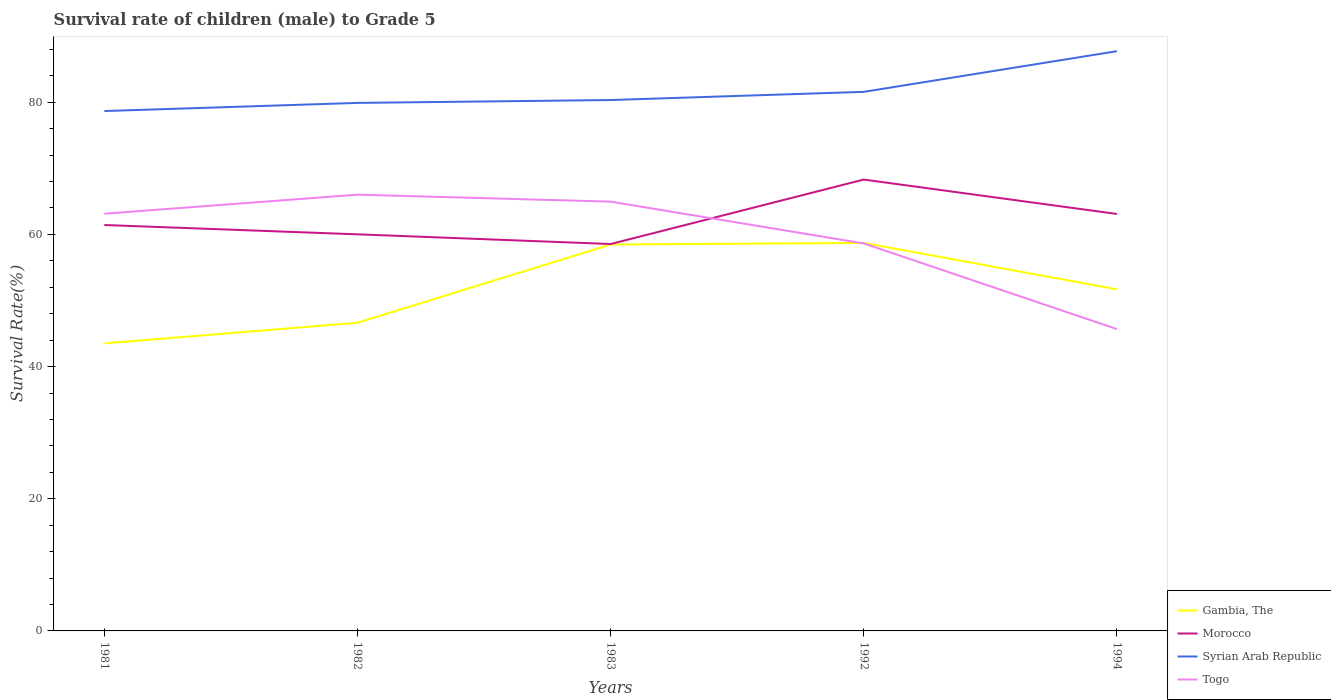Is the number of lines equal to the number of legend labels?
Provide a succinct answer. Yes. Across all years, what is the maximum survival rate of male children to grade 5 in Syrian Arab Republic?
Provide a short and direct response. 78.67. What is the total survival rate of male children to grade 5 in Gambia, The in the graph?
Give a very brief answer. -14.96. What is the difference between the highest and the second highest survival rate of male children to grade 5 in Morocco?
Offer a terse response. 9.75. Is the survival rate of male children to grade 5 in Togo strictly greater than the survival rate of male children to grade 5 in Morocco over the years?
Your response must be concise. No. How many years are there in the graph?
Your answer should be very brief. 5. What is the difference between two consecutive major ticks on the Y-axis?
Your answer should be very brief. 20. Where does the legend appear in the graph?
Give a very brief answer. Bottom right. How many legend labels are there?
Keep it short and to the point. 4. What is the title of the graph?
Make the answer very short. Survival rate of children (male) to Grade 5. Does "Argentina" appear as one of the legend labels in the graph?
Ensure brevity in your answer.  No. What is the label or title of the X-axis?
Provide a succinct answer. Years. What is the label or title of the Y-axis?
Ensure brevity in your answer.  Survival Rate(%). What is the Survival Rate(%) of Gambia, The in 1981?
Your response must be concise. 43.51. What is the Survival Rate(%) of Morocco in 1981?
Make the answer very short. 61.42. What is the Survival Rate(%) in Syrian Arab Republic in 1981?
Your response must be concise. 78.67. What is the Survival Rate(%) of Togo in 1981?
Offer a very short reply. 63.13. What is the Survival Rate(%) in Gambia, The in 1982?
Your answer should be compact. 46.63. What is the Survival Rate(%) in Morocco in 1982?
Your answer should be compact. 60.01. What is the Survival Rate(%) of Syrian Arab Republic in 1982?
Make the answer very short. 79.9. What is the Survival Rate(%) in Togo in 1982?
Offer a very short reply. 66.01. What is the Survival Rate(%) of Gambia, The in 1983?
Give a very brief answer. 58.47. What is the Survival Rate(%) in Morocco in 1983?
Ensure brevity in your answer.  58.55. What is the Survival Rate(%) in Syrian Arab Republic in 1983?
Your answer should be compact. 80.33. What is the Survival Rate(%) in Togo in 1983?
Your answer should be compact. 64.96. What is the Survival Rate(%) in Gambia, The in 1992?
Ensure brevity in your answer.  58.71. What is the Survival Rate(%) of Morocco in 1992?
Provide a succinct answer. 68.3. What is the Survival Rate(%) of Syrian Arab Republic in 1992?
Ensure brevity in your answer.  81.57. What is the Survival Rate(%) in Togo in 1992?
Your answer should be very brief. 58.63. What is the Survival Rate(%) in Gambia, The in 1994?
Provide a succinct answer. 51.69. What is the Survival Rate(%) in Morocco in 1994?
Keep it short and to the point. 63.09. What is the Survival Rate(%) in Syrian Arab Republic in 1994?
Provide a short and direct response. 87.72. What is the Survival Rate(%) of Togo in 1994?
Keep it short and to the point. 45.67. Across all years, what is the maximum Survival Rate(%) in Gambia, The?
Give a very brief answer. 58.71. Across all years, what is the maximum Survival Rate(%) of Morocco?
Provide a succinct answer. 68.3. Across all years, what is the maximum Survival Rate(%) of Syrian Arab Republic?
Provide a succinct answer. 87.72. Across all years, what is the maximum Survival Rate(%) of Togo?
Provide a short and direct response. 66.01. Across all years, what is the minimum Survival Rate(%) of Gambia, The?
Offer a terse response. 43.51. Across all years, what is the minimum Survival Rate(%) in Morocco?
Keep it short and to the point. 58.55. Across all years, what is the minimum Survival Rate(%) of Syrian Arab Republic?
Offer a terse response. 78.67. Across all years, what is the minimum Survival Rate(%) of Togo?
Offer a terse response. 45.67. What is the total Survival Rate(%) in Gambia, The in the graph?
Offer a terse response. 259.01. What is the total Survival Rate(%) in Morocco in the graph?
Make the answer very short. 311.37. What is the total Survival Rate(%) in Syrian Arab Republic in the graph?
Provide a succinct answer. 408.19. What is the total Survival Rate(%) of Togo in the graph?
Provide a short and direct response. 298.41. What is the difference between the Survival Rate(%) of Gambia, The in 1981 and that in 1982?
Keep it short and to the point. -3.13. What is the difference between the Survival Rate(%) in Morocco in 1981 and that in 1982?
Give a very brief answer. 1.41. What is the difference between the Survival Rate(%) in Syrian Arab Republic in 1981 and that in 1982?
Offer a very short reply. -1.23. What is the difference between the Survival Rate(%) in Togo in 1981 and that in 1982?
Offer a terse response. -2.88. What is the difference between the Survival Rate(%) of Gambia, The in 1981 and that in 1983?
Your response must be concise. -14.96. What is the difference between the Survival Rate(%) of Morocco in 1981 and that in 1983?
Give a very brief answer. 2.87. What is the difference between the Survival Rate(%) in Syrian Arab Republic in 1981 and that in 1983?
Offer a very short reply. -1.67. What is the difference between the Survival Rate(%) of Togo in 1981 and that in 1983?
Your answer should be very brief. -1.83. What is the difference between the Survival Rate(%) in Gambia, The in 1981 and that in 1992?
Provide a short and direct response. -15.2. What is the difference between the Survival Rate(%) in Morocco in 1981 and that in 1992?
Make the answer very short. -6.88. What is the difference between the Survival Rate(%) of Syrian Arab Republic in 1981 and that in 1992?
Your answer should be very brief. -2.9. What is the difference between the Survival Rate(%) in Togo in 1981 and that in 1992?
Provide a succinct answer. 4.49. What is the difference between the Survival Rate(%) of Gambia, The in 1981 and that in 1994?
Make the answer very short. -8.18. What is the difference between the Survival Rate(%) in Morocco in 1981 and that in 1994?
Offer a terse response. -1.67. What is the difference between the Survival Rate(%) in Syrian Arab Republic in 1981 and that in 1994?
Keep it short and to the point. -9.06. What is the difference between the Survival Rate(%) of Togo in 1981 and that in 1994?
Provide a short and direct response. 17.46. What is the difference between the Survival Rate(%) of Gambia, The in 1982 and that in 1983?
Provide a short and direct response. -11.84. What is the difference between the Survival Rate(%) of Morocco in 1982 and that in 1983?
Offer a terse response. 1.47. What is the difference between the Survival Rate(%) of Syrian Arab Republic in 1982 and that in 1983?
Provide a succinct answer. -0.44. What is the difference between the Survival Rate(%) of Togo in 1982 and that in 1983?
Your answer should be very brief. 1.06. What is the difference between the Survival Rate(%) of Gambia, The in 1982 and that in 1992?
Provide a succinct answer. -12.07. What is the difference between the Survival Rate(%) in Morocco in 1982 and that in 1992?
Your response must be concise. -8.29. What is the difference between the Survival Rate(%) in Syrian Arab Republic in 1982 and that in 1992?
Provide a short and direct response. -1.67. What is the difference between the Survival Rate(%) in Togo in 1982 and that in 1992?
Offer a terse response. 7.38. What is the difference between the Survival Rate(%) in Gambia, The in 1982 and that in 1994?
Your answer should be compact. -5.06. What is the difference between the Survival Rate(%) of Morocco in 1982 and that in 1994?
Your answer should be compact. -3.08. What is the difference between the Survival Rate(%) of Syrian Arab Republic in 1982 and that in 1994?
Make the answer very short. -7.83. What is the difference between the Survival Rate(%) of Togo in 1982 and that in 1994?
Keep it short and to the point. 20.34. What is the difference between the Survival Rate(%) in Gambia, The in 1983 and that in 1992?
Offer a very short reply. -0.24. What is the difference between the Survival Rate(%) of Morocco in 1983 and that in 1992?
Ensure brevity in your answer.  -9.75. What is the difference between the Survival Rate(%) in Syrian Arab Republic in 1983 and that in 1992?
Provide a short and direct response. -1.24. What is the difference between the Survival Rate(%) in Togo in 1983 and that in 1992?
Your response must be concise. 6.32. What is the difference between the Survival Rate(%) in Gambia, The in 1983 and that in 1994?
Your response must be concise. 6.78. What is the difference between the Survival Rate(%) of Morocco in 1983 and that in 1994?
Offer a terse response. -4.55. What is the difference between the Survival Rate(%) in Syrian Arab Republic in 1983 and that in 1994?
Offer a very short reply. -7.39. What is the difference between the Survival Rate(%) in Togo in 1983 and that in 1994?
Your answer should be compact. 19.28. What is the difference between the Survival Rate(%) of Gambia, The in 1992 and that in 1994?
Your answer should be very brief. 7.02. What is the difference between the Survival Rate(%) in Morocco in 1992 and that in 1994?
Your answer should be compact. 5.2. What is the difference between the Survival Rate(%) in Syrian Arab Republic in 1992 and that in 1994?
Offer a very short reply. -6.15. What is the difference between the Survival Rate(%) of Togo in 1992 and that in 1994?
Your response must be concise. 12.96. What is the difference between the Survival Rate(%) in Gambia, The in 1981 and the Survival Rate(%) in Morocco in 1982?
Keep it short and to the point. -16.5. What is the difference between the Survival Rate(%) of Gambia, The in 1981 and the Survival Rate(%) of Syrian Arab Republic in 1982?
Ensure brevity in your answer.  -36.39. What is the difference between the Survival Rate(%) in Gambia, The in 1981 and the Survival Rate(%) in Togo in 1982?
Offer a very short reply. -22.51. What is the difference between the Survival Rate(%) of Morocco in 1981 and the Survival Rate(%) of Syrian Arab Republic in 1982?
Your answer should be very brief. -18.48. What is the difference between the Survival Rate(%) in Morocco in 1981 and the Survival Rate(%) in Togo in 1982?
Keep it short and to the point. -4.59. What is the difference between the Survival Rate(%) in Syrian Arab Republic in 1981 and the Survival Rate(%) in Togo in 1982?
Give a very brief answer. 12.65. What is the difference between the Survival Rate(%) of Gambia, The in 1981 and the Survival Rate(%) of Morocco in 1983?
Provide a succinct answer. -15.04. What is the difference between the Survival Rate(%) of Gambia, The in 1981 and the Survival Rate(%) of Syrian Arab Republic in 1983?
Provide a short and direct response. -36.83. What is the difference between the Survival Rate(%) of Gambia, The in 1981 and the Survival Rate(%) of Togo in 1983?
Your answer should be compact. -21.45. What is the difference between the Survival Rate(%) in Morocco in 1981 and the Survival Rate(%) in Syrian Arab Republic in 1983?
Your answer should be very brief. -18.91. What is the difference between the Survival Rate(%) in Morocco in 1981 and the Survival Rate(%) in Togo in 1983?
Ensure brevity in your answer.  -3.54. What is the difference between the Survival Rate(%) of Syrian Arab Republic in 1981 and the Survival Rate(%) of Togo in 1983?
Your answer should be very brief. 13.71. What is the difference between the Survival Rate(%) of Gambia, The in 1981 and the Survival Rate(%) of Morocco in 1992?
Offer a terse response. -24.79. What is the difference between the Survival Rate(%) in Gambia, The in 1981 and the Survival Rate(%) in Syrian Arab Republic in 1992?
Offer a very short reply. -38.06. What is the difference between the Survival Rate(%) of Gambia, The in 1981 and the Survival Rate(%) of Togo in 1992?
Your response must be concise. -15.13. What is the difference between the Survival Rate(%) of Morocco in 1981 and the Survival Rate(%) of Syrian Arab Republic in 1992?
Make the answer very short. -20.15. What is the difference between the Survival Rate(%) of Morocco in 1981 and the Survival Rate(%) of Togo in 1992?
Your response must be concise. 2.78. What is the difference between the Survival Rate(%) in Syrian Arab Republic in 1981 and the Survival Rate(%) in Togo in 1992?
Offer a terse response. 20.03. What is the difference between the Survival Rate(%) in Gambia, The in 1981 and the Survival Rate(%) in Morocco in 1994?
Give a very brief answer. -19.59. What is the difference between the Survival Rate(%) of Gambia, The in 1981 and the Survival Rate(%) of Syrian Arab Republic in 1994?
Offer a very short reply. -44.22. What is the difference between the Survival Rate(%) of Gambia, The in 1981 and the Survival Rate(%) of Togo in 1994?
Keep it short and to the point. -2.17. What is the difference between the Survival Rate(%) of Morocco in 1981 and the Survival Rate(%) of Syrian Arab Republic in 1994?
Your response must be concise. -26.3. What is the difference between the Survival Rate(%) in Morocco in 1981 and the Survival Rate(%) in Togo in 1994?
Make the answer very short. 15.75. What is the difference between the Survival Rate(%) of Syrian Arab Republic in 1981 and the Survival Rate(%) of Togo in 1994?
Your answer should be compact. 32.99. What is the difference between the Survival Rate(%) of Gambia, The in 1982 and the Survival Rate(%) of Morocco in 1983?
Your response must be concise. -11.91. What is the difference between the Survival Rate(%) of Gambia, The in 1982 and the Survival Rate(%) of Syrian Arab Republic in 1983?
Offer a very short reply. -33.7. What is the difference between the Survival Rate(%) in Gambia, The in 1982 and the Survival Rate(%) in Togo in 1983?
Offer a very short reply. -18.32. What is the difference between the Survival Rate(%) in Morocco in 1982 and the Survival Rate(%) in Syrian Arab Republic in 1983?
Give a very brief answer. -20.32. What is the difference between the Survival Rate(%) in Morocco in 1982 and the Survival Rate(%) in Togo in 1983?
Ensure brevity in your answer.  -4.95. What is the difference between the Survival Rate(%) in Syrian Arab Republic in 1982 and the Survival Rate(%) in Togo in 1983?
Offer a terse response. 14.94. What is the difference between the Survival Rate(%) of Gambia, The in 1982 and the Survival Rate(%) of Morocco in 1992?
Make the answer very short. -21.66. What is the difference between the Survival Rate(%) of Gambia, The in 1982 and the Survival Rate(%) of Syrian Arab Republic in 1992?
Provide a succinct answer. -34.94. What is the difference between the Survival Rate(%) of Gambia, The in 1982 and the Survival Rate(%) of Togo in 1992?
Offer a terse response. -12. What is the difference between the Survival Rate(%) in Morocco in 1982 and the Survival Rate(%) in Syrian Arab Republic in 1992?
Make the answer very short. -21.56. What is the difference between the Survival Rate(%) in Morocco in 1982 and the Survival Rate(%) in Togo in 1992?
Keep it short and to the point. 1.38. What is the difference between the Survival Rate(%) of Syrian Arab Republic in 1982 and the Survival Rate(%) of Togo in 1992?
Make the answer very short. 21.26. What is the difference between the Survival Rate(%) of Gambia, The in 1982 and the Survival Rate(%) of Morocco in 1994?
Offer a terse response. -16.46. What is the difference between the Survival Rate(%) in Gambia, The in 1982 and the Survival Rate(%) in Syrian Arab Republic in 1994?
Offer a terse response. -41.09. What is the difference between the Survival Rate(%) in Gambia, The in 1982 and the Survival Rate(%) in Togo in 1994?
Provide a short and direct response. 0.96. What is the difference between the Survival Rate(%) in Morocco in 1982 and the Survival Rate(%) in Syrian Arab Republic in 1994?
Provide a short and direct response. -27.71. What is the difference between the Survival Rate(%) of Morocco in 1982 and the Survival Rate(%) of Togo in 1994?
Your response must be concise. 14.34. What is the difference between the Survival Rate(%) of Syrian Arab Republic in 1982 and the Survival Rate(%) of Togo in 1994?
Your response must be concise. 34.22. What is the difference between the Survival Rate(%) of Gambia, The in 1983 and the Survival Rate(%) of Morocco in 1992?
Give a very brief answer. -9.83. What is the difference between the Survival Rate(%) of Gambia, The in 1983 and the Survival Rate(%) of Syrian Arab Republic in 1992?
Make the answer very short. -23.1. What is the difference between the Survival Rate(%) of Gambia, The in 1983 and the Survival Rate(%) of Togo in 1992?
Ensure brevity in your answer.  -0.16. What is the difference between the Survival Rate(%) in Morocco in 1983 and the Survival Rate(%) in Syrian Arab Republic in 1992?
Provide a succinct answer. -23.02. What is the difference between the Survival Rate(%) in Morocco in 1983 and the Survival Rate(%) in Togo in 1992?
Provide a succinct answer. -0.09. What is the difference between the Survival Rate(%) in Syrian Arab Republic in 1983 and the Survival Rate(%) in Togo in 1992?
Your answer should be compact. 21.7. What is the difference between the Survival Rate(%) in Gambia, The in 1983 and the Survival Rate(%) in Morocco in 1994?
Make the answer very short. -4.62. What is the difference between the Survival Rate(%) in Gambia, The in 1983 and the Survival Rate(%) in Syrian Arab Republic in 1994?
Make the answer very short. -29.25. What is the difference between the Survival Rate(%) in Gambia, The in 1983 and the Survival Rate(%) in Togo in 1994?
Give a very brief answer. 12.8. What is the difference between the Survival Rate(%) in Morocco in 1983 and the Survival Rate(%) in Syrian Arab Republic in 1994?
Your response must be concise. -29.18. What is the difference between the Survival Rate(%) of Morocco in 1983 and the Survival Rate(%) of Togo in 1994?
Your answer should be compact. 12.87. What is the difference between the Survival Rate(%) of Syrian Arab Republic in 1983 and the Survival Rate(%) of Togo in 1994?
Your answer should be compact. 34.66. What is the difference between the Survival Rate(%) in Gambia, The in 1992 and the Survival Rate(%) in Morocco in 1994?
Keep it short and to the point. -4.38. What is the difference between the Survival Rate(%) of Gambia, The in 1992 and the Survival Rate(%) of Syrian Arab Republic in 1994?
Keep it short and to the point. -29.02. What is the difference between the Survival Rate(%) in Gambia, The in 1992 and the Survival Rate(%) in Togo in 1994?
Give a very brief answer. 13.03. What is the difference between the Survival Rate(%) of Morocco in 1992 and the Survival Rate(%) of Syrian Arab Republic in 1994?
Offer a very short reply. -19.43. What is the difference between the Survival Rate(%) in Morocco in 1992 and the Survival Rate(%) in Togo in 1994?
Keep it short and to the point. 22.62. What is the difference between the Survival Rate(%) of Syrian Arab Republic in 1992 and the Survival Rate(%) of Togo in 1994?
Provide a short and direct response. 35.9. What is the average Survival Rate(%) in Gambia, The per year?
Your answer should be very brief. 51.8. What is the average Survival Rate(%) in Morocco per year?
Provide a short and direct response. 62.27. What is the average Survival Rate(%) of Syrian Arab Republic per year?
Your answer should be compact. 81.64. What is the average Survival Rate(%) in Togo per year?
Your response must be concise. 59.68. In the year 1981, what is the difference between the Survival Rate(%) in Gambia, The and Survival Rate(%) in Morocco?
Offer a terse response. -17.91. In the year 1981, what is the difference between the Survival Rate(%) of Gambia, The and Survival Rate(%) of Syrian Arab Republic?
Offer a terse response. -35.16. In the year 1981, what is the difference between the Survival Rate(%) in Gambia, The and Survival Rate(%) in Togo?
Offer a terse response. -19.62. In the year 1981, what is the difference between the Survival Rate(%) in Morocco and Survival Rate(%) in Syrian Arab Republic?
Your answer should be compact. -17.25. In the year 1981, what is the difference between the Survival Rate(%) of Morocco and Survival Rate(%) of Togo?
Provide a short and direct response. -1.71. In the year 1981, what is the difference between the Survival Rate(%) in Syrian Arab Republic and Survival Rate(%) in Togo?
Ensure brevity in your answer.  15.54. In the year 1982, what is the difference between the Survival Rate(%) in Gambia, The and Survival Rate(%) in Morocco?
Your answer should be compact. -13.38. In the year 1982, what is the difference between the Survival Rate(%) in Gambia, The and Survival Rate(%) in Syrian Arab Republic?
Your response must be concise. -33.26. In the year 1982, what is the difference between the Survival Rate(%) in Gambia, The and Survival Rate(%) in Togo?
Your response must be concise. -19.38. In the year 1982, what is the difference between the Survival Rate(%) of Morocco and Survival Rate(%) of Syrian Arab Republic?
Offer a very short reply. -19.88. In the year 1982, what is the difference between the Survival Rate(%) of Morocco and Survival Rate(%) of Togo?
Keep it short and to the point. -6. In the year 1982, what is the difference between the Survival Rate(%) of Syrian Arab Republic and Survival Rate(%) of Togo?
Give a very brief answer. 13.88. In the year 1983, what is the difference between the Survival Rate(%) of Gambia, The and Survival Rate(%) of Morocco?
Give a very brief answer. -0.08. In the year 1983, what is the difference between the Survival Rate(%) in Gambia, The and Survival Rate(%) in Syrian Arab Republic?
Ensure brevity in your answer.  -21.86. In the year 1983, what is the difference between the Survival Rate(%) of Gambia, The and Survival Rate(%) of Togo?
Offer a terse response. -6.49. In the year 1983, what is the difference between the Survival Rate(%) of Morocco and Survival Rate(%) of Syrian Arab Republic?
Ensure brevity in your answer.  -21.79. In the year 1983, what is the difference between the Survival Rate(%) in Morocco and Survival Rate(%) in Togo?
Your answer should be compact. -6.41. In the year 1983, what is the difference between the Survival Rate(%) of Syrian Arab Republic and Survival Rate(%) of Togo?
Provide a short and direct response. 15.38. In the year 1992, what is the difference between the Survival Rate(%) of Gambia, The and Survival Rate(%) of Morocco?
Provide a succinct answer. -9.59. In the year 1992, what is the difference between the Survival Rate(%) in Gambia, The and Survival Rate(%) in Syrian Arab Republic?
Give a very brief answer. -22.86. In the year 1992, what is the difference between the Survival Rate(%) of Gambia, The and Survival Rate(%) of Togo?
Make the answer very short. 0.07. In the year 1992, what is the difference between the Survival Rate(%) in Morocco and Survival Rate(%) in Syrian Arab Republic?
Your answer should be compact. -13.27. In the year 1992, what is the difference between the Survival Rate(%) in Morocco and Survival Rate(%) in Togo?
Your answer should be very brief. 9.66. In the year 1992, what is the difference between the Survival Rate(%) in Syrian Arab Republic and Survival Rate(%) in Togo?
Offer a very short reply. 22.93. In the year 1994, what is the difference between the Survival Rate(%) in Gambia, The and Survival Rate(%) in Morocco?
Keep it short and to the point. -11.4. In the year 1994, what is the difference between the Survival Rate(%) of Gambia, The and Survival Rate(%) of Syrian Arab Republic?
Offer a terse response. -36.03. In the year 1994, what is the difference between the Survival Rate(%) in Gambia, The and Survival Rate(%) in Togo?
Ensure brevity in your answer.  6.02. In the year 1994, what is the difference between the Survival Rate(%) of Morocco and Survival Rate(%) of Syrian Arab Republic?
Your response must be concise. -24.63. In the year 1994, what is the difference between the Survival Rate(%) of Morocco and Survival Rate(%) of Togo?
Your answer should be compact. 17.42. In the year 1994, what is the difference between the Survival Rate(%) in Syrian Arab Republic and Survival Rate(%) in Togo?
Your answer should be compact. 42.05. What is the ratio of the Survival Rate(%) of Gambia, The in 1981 to that in 1982?
Offer a terse response. 0.93. What is the ratio of the Survival Rate(%) of Morocco in 1981 to that in 1982?
Give a very brief answer. 1.02. What is the ratio of the Survival Rate(%) of Syrian Arab Republic in 1981 to that in 1982?
Provide a succinct answer. 0.98. What is the ratio of the Survival Rate(%) in Togo in 1981 to that in 1982?
Your answer should be compact. 0.96. What is the ratio of the Survival Rate(%) in Gambia, The in 1981 to that in 1983?
Your answer should be very brief. 0.74. What is the ratio of the Survival Rate(%) in Morocco in 1981 to that in 1983?
Your answer should be compact. 1.05. What is the ratio of the Survival Rate(%) in Syrian Arab Republic in 1981 to that in 1983?
Provide a short and direct response. 0.98. What is the ratio of the Survival Rate(%) in Togo in 1981 to that in 1983?
Provide a succinct answer. 0.97. What is the ratio of the Survival Rate(%) of Gambia, The in 1981 to that in 1992?
Offer a terse response. 0.74. What is the ratio of the Survival Rate(%) of Morocco in 1981 to that in 1992?
Make the answer very short. 0.9. What is the ratio of the Survival Rate(%) in Syrian Arab Republic in 1981 to that in 1992?
Offer a terse response. 0.96. What is the ratio of the Survival Rate(%) in Togo in 1981 to that in 1992?
Your response must be concise. 1.08. What is the ratio of the Survival Rate(%) in Gambia, The in 1981 to that in 1994?
Give a very brief answer. 0.84. What is the ratio of the Survival Rate(%) of Morocco in 1981 to that in 1994?
Keep it short and to the point. 0.97. What is the ratio of the Survival Rate(%) in Syrian Arab Republic in 1981 to that in 1994?
Your answer should be very brief. 0.9. What is the ratio of the Survival Rate(%) of Togo in 1981 to that in 1994?
Your response must be concise. 1.38. What is the ratio of the Survival Rate(%) in Gambia, The in 1982 to that in 1983?
Offer a terse response. 0.8. What is the ratio of the Survival Rate(%) of Togo in 1982 to that in 1983?
Ensure brevity in your answer.  1.02. What is the ratio of the Survival Rate(%) in Gambia, The in 1982 to that in 1992?
Ensure brevity in your answer.  0.79. What is the ratio of the Survival Rate(%) of Morocco in 1982 to that in 1992?
Provide a short and direct response. 0.88. What is the ratio of the Survival Rate(%) in Syrian Arab Republic in 1982 to that in 1992?
Ensure brevity in your answer.  0.98. What is the ratio of the Survival Rate(%) in Togo in 1982 to that in 1992?
Ensure brevity in your answer.  1.13. What is the ratio of the Survival Rate(%) in Gambia, The in 1982 to that in 1994?
Offer a terse response. 0.9. What is the ratio of the Survival Rate(%) of Morocco in 1982 to that in 1994?
Make the answer very short. 0.95. What is the ratio of the Survival Rate(%) in Syrian Arab Republic in 1982 to that in 1994?
Offer a terse response. 0.91. What is the ratio of the Survival Rate(%) of Togo in 1982 to that in 1994?
Your response must be concise. 1.45. What is the ratio of the Survival Rate(%) of Morocco in 1983 to that in 1992?
Offer a terse response. 0.86. What is the ratio of the Survival Rate(%) of Togo in 1983 to that in 1992?
Your response must be concise. 1.11. What is the ratio of the Survival Rate(%) of Gambia, The in 1983 to that in 1994?
Offer a very short reply. 1.13. What is the ratio of the Survival Rate(%) of Morocco in 1983 to that in 1994?
Your answer should be compact. 0.93. What is the ratio of the Survival Rate(%) in Syrian Arab Republic in 1983 to that in 1994?
Keep it short and to the point. 0.92. What is the ratio of the Survival Rate(%) of Togo in 1983 to that in 1994?
Keep it short and to the point. 1.42. What is the ratio of the Survival Rate(%) of Gambia, The in 1992 to that in 1994?
Your answer should be compact. 1.14. What is the ratio of the Survival Rate(%) of Morocco in 1992 to that in 1994?
Your answer should be very brief. 1.08. What is the ratio of the Survival Rate(%) in Syrian Arab Republic in 1992 to that in 1994?
Make the answer very short. 0.93. What is the ratio of the Survival Rate(%) of Togo in 1992 to that in 1994?
Offer a very short reply. 1.28. What is the difference between the highest and the second highest Survival Rate(%) of Gambia, The?
Your answer should be compact. 0.24. What is the difference between the highest and the second highest Survival Rate(%) in Morocco?
Keep it short and to the point. 5.2. What is the difference between the highest and the second highest Survival Rate(%) of Syrian Arab Republic?
Offer a very short reply. 6.15. What is the difference between the highest and the second highest Survival Rate(%) in Togo?
Provide a short and direct response. 1.06. What is the difference between the highest and the lowest Survival Rate(%) in Gambia, The?
Your answer should be compact. 15.2. What is the difference between the highest and the lowest Survival Rate(%) of Morocco?
Give a very brief answer. 9.75. What is the difference between the highest and the lowest Survival Rate(%) of Syrian Arab Republic?
Ensure brevity in your answer.  9.06. What is the difference between the highest and the lowest Survival Rate(%) of Togo?
Your answer should be very brief. 20.34. 